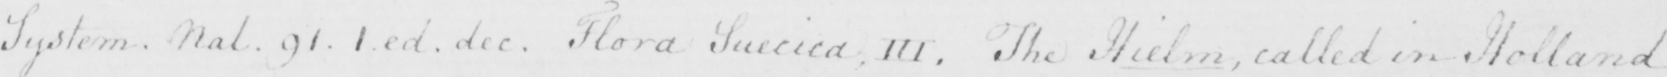Can you read and transcribe this handwriting? System . Nal . 91 . 1 . ed . dec . Flora Suecica , III . The Hielm , called in Holland 